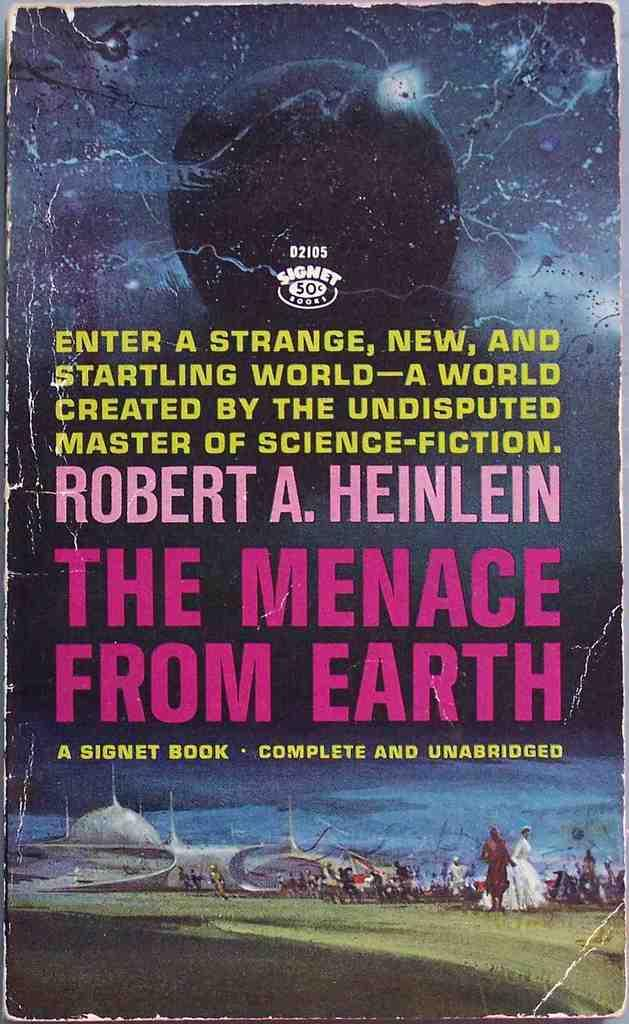Provide a one-sentence caption for the provided image. Dogeared paperback book by Robert A Heinlein "The Menace From Earth.". 